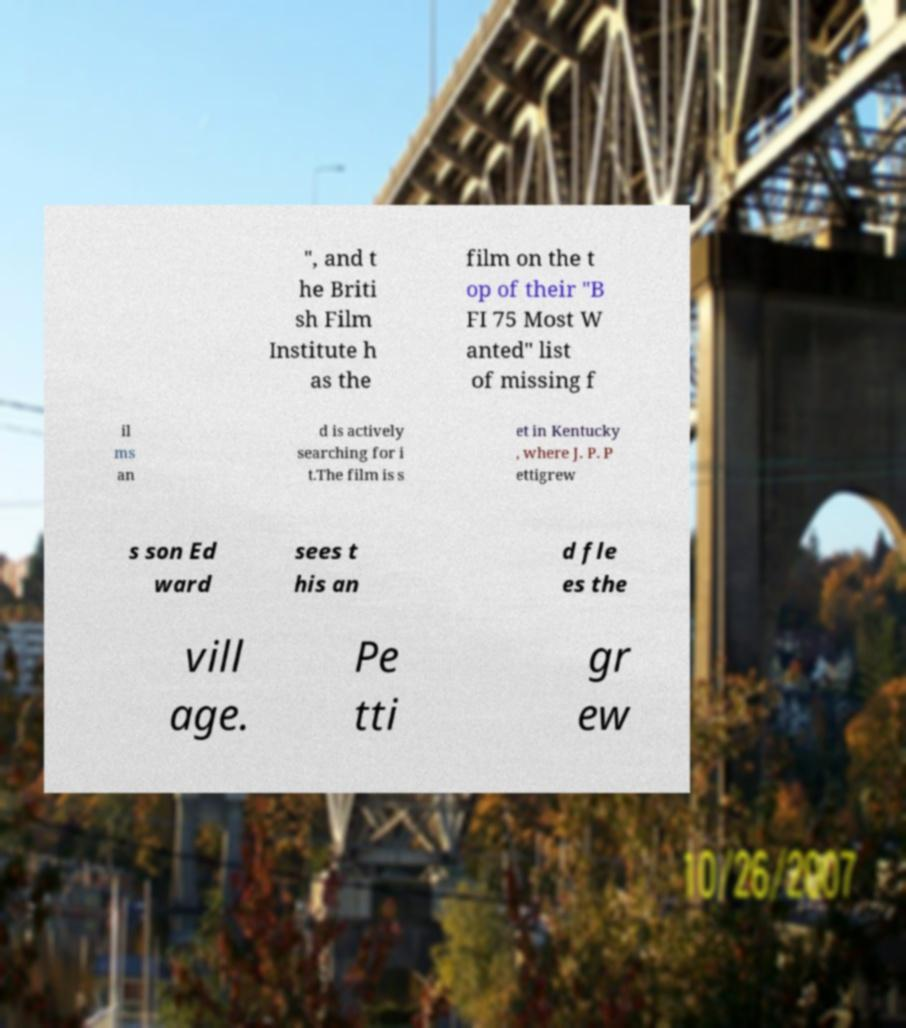I need the written content from this picture converted into text. Can you do that? ", and t he Briti sh Film Institute h as the film on the t op of their "B FI 75 Most W anted" list of missing f il ms an d is actively searching for i t.The film is s et in Kentucky , where J. P. P ettigrew s son Ed ward sees t his an d fle es the vill age. Pe tti gr ew 